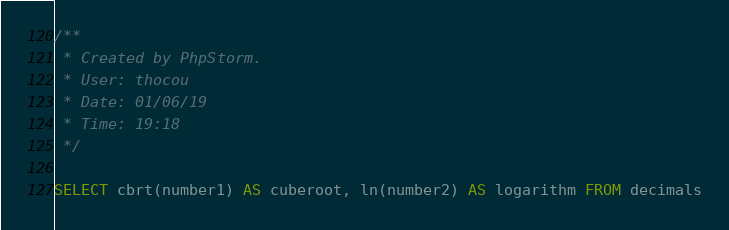<code> <loc_0><loc_0><loc_500><loc_500><_SQL_>/**
 * Created by PhpStorm.
 * User: thocou
 * Date: 01/06/19
 * Time: 19:18
 */

SELECT cbrt(number1) AS cuberoot, ln(number2) AS logarithm FROM decimals
</code> 